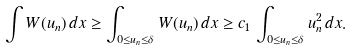<formula> <loc_0><loc_0><loc_500><loc_500>\int W ( u _ { n } ) \, d x \geq \int _ { 0 \leq u _ { n } \leq \delta } W ( u _ { n } ) \, d x \geq c _ { 1 } \, \int _ { 0 \leq u _ { n } \leq \delta } u _ { n } ^ { 2 } \, d x .</formula> 